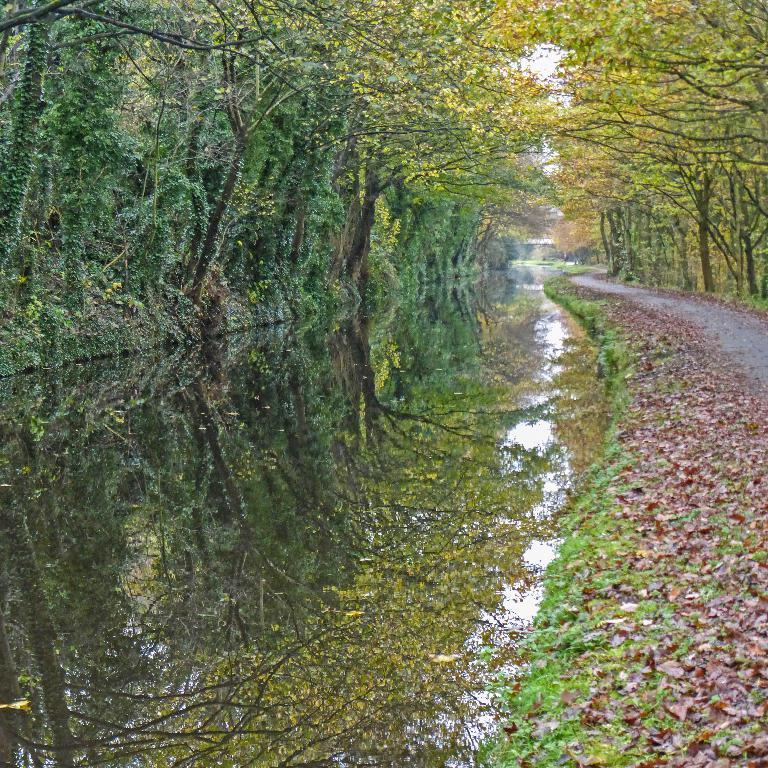What type of vegetation is present in the front of the image? There are dry leaves and grass in the front of the image. What can be seen in the background of the image? There are trees in the background of the image. What type of credit card is visible in the image? There is no credit card present in the image. Is there any crime being committed in the image? There is no indication of any crime being committed in the image. 